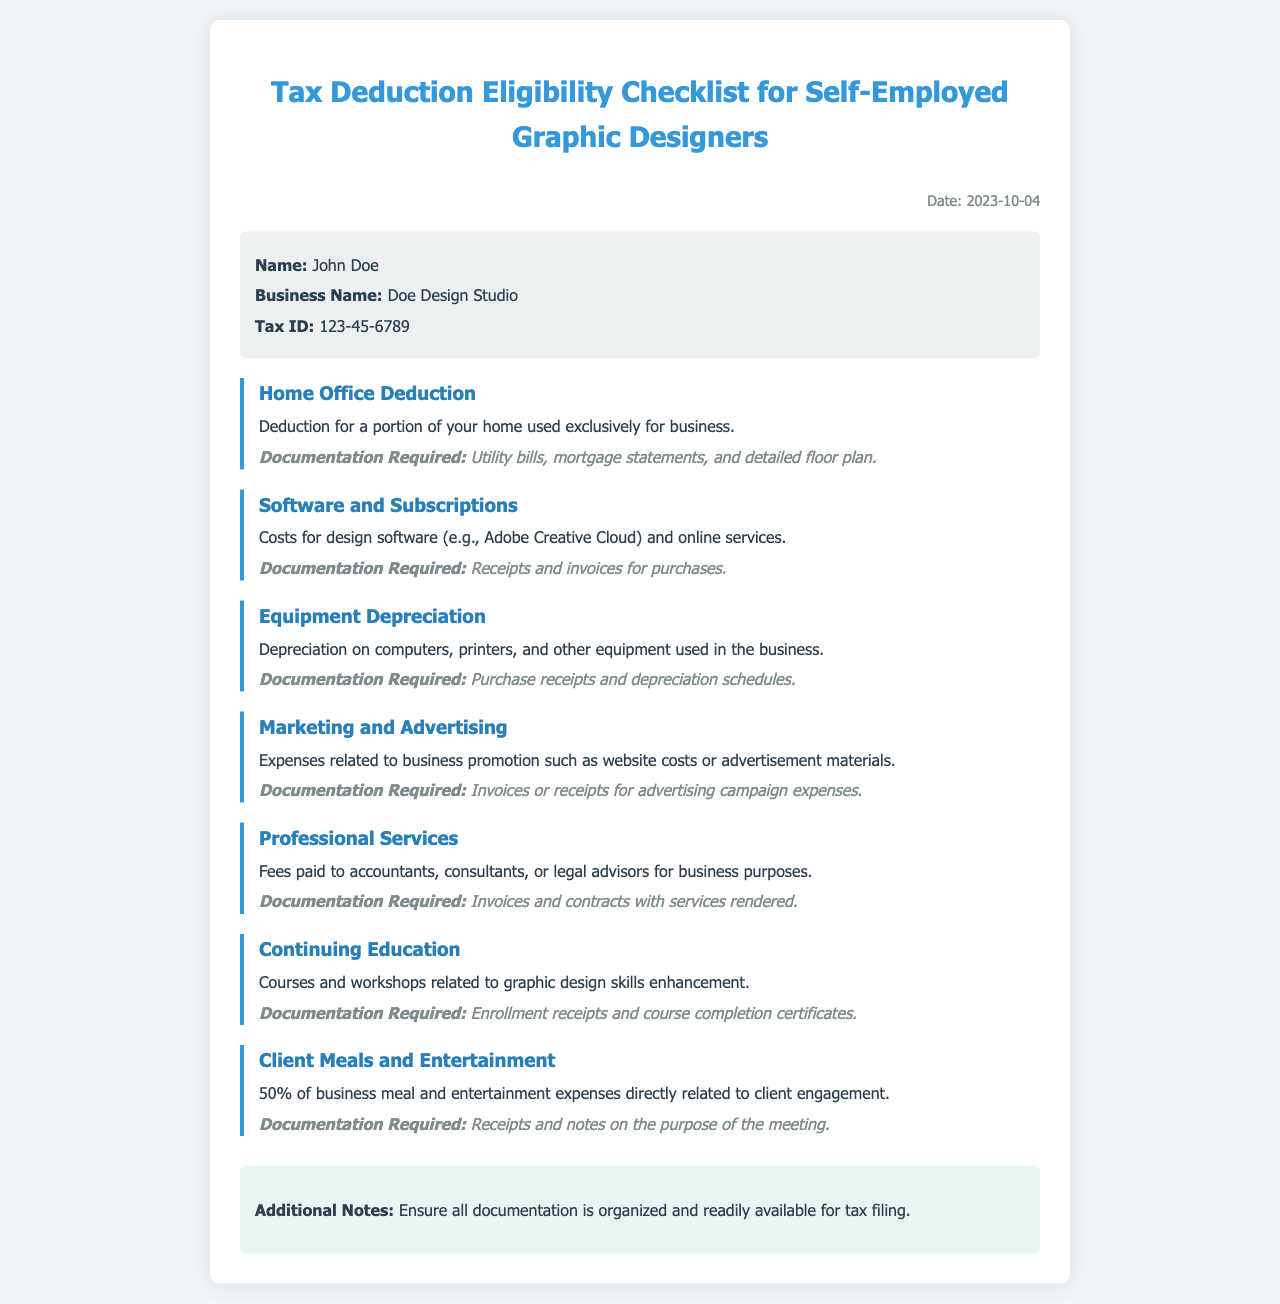What is the name of the self-employed individual? The name of the self-employed individual is listed under the personal info section of the document, which is John Doe.
Answer: John Doe What is the business name of the individual? The business name is provided in the personal info section, identified as Doe Design Studio.
Answer: Doe Design Studio What is the date of the document? The date is mentioned in the document header, which states the date as 2023-10-04.
Answer: 2023-10-04 What type of expenses are related to design software? The expenses related to design software are categorized under Software and Subscriptions in the document.
Answer: Software and Subscriptions How much of the client meal expenses is deductible? The document specifies that 50% of business meal expenses are deductible, stating this explicitly under Client Meals and Entertainment.
Answer: 50% What documentation is required for Home Office Deduction? The document details that utility bills, mortgage statements, and detailed floor plans are required documentation for this deduction.
Answer: Utility bills, mortgage statements, and detailed floor plan What should be included in the documentation for Professional Services? The document notes that invoices and contracts with services rendered are necessary for documenting Professional Services expenses.
Answer: Invoices and contracts What type of education expenses can be deducted? Continuing education courses and workshops related to graphic design skills enhancement can be deducted as stated in the document.
Answer: Courses and workshops What additional note is mentioned at the end of the document? The document includes an additional note advising to ensure all documentation is organized and readily available for tax filing.
Answer: Ensure all documentation is organized and readily available for tax filing 